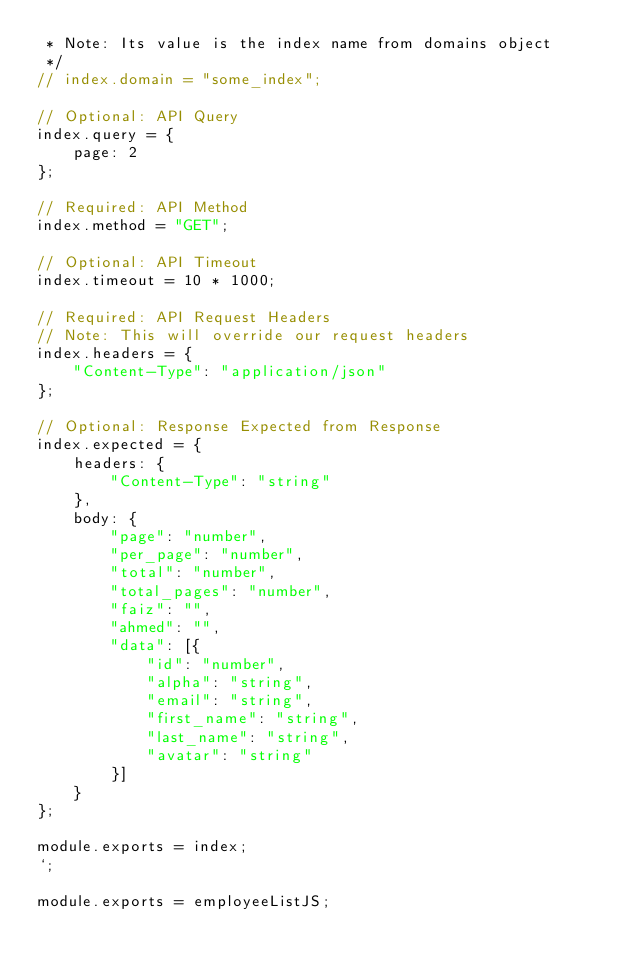<code> <loc_0><loc_0><loc_500><loc_500><_JavaScript_> * Note: Its value is the index name from domains object
 */
// index.domain = "some_index";

// Optional: API Query
index.query = {
	page: 2
};

// Required: API Method
index.method = "GET";

// Optional: API Timeout
index.timeout = 10 * 1000;

// Required: API Request Headers
// Note: This will override our request headers
index.headers = {
	"Content-Type": "application/json"
};

// Optional: Response Expected from Response
index.expected = {
	headers: {
		"Content-Type": "string"
	},
	body: {
		"page": "number",
		"per_page": "number",
		"total": "number",
		"total_pages": "number",
		"faiz": "",
		"ahmed": "",
		"data": [{
			"id": "number",
			"alpha": "string",
			"email": "string",
			"first_name": "string",
			"last_name": "string",
			"avatar": "string"
		}]
	}
};

module.exports = index;
`;

module.exports = employeeListJS;
</code> 